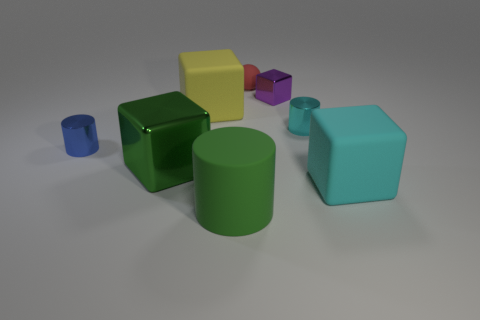Add 2 big yellow objects. How many objects exist? 10 Subtract all cylinders. How many objects are left? 5 Subtract 1 green cubes. How many objects are left? 7 Subtract all large green cylinders. Subtract all tiny purple shiny cubes. How many objects are left? 6 Add 8 metal cubes. How many metal cubes are left? 10 Add 5 gray matte things. How many gray matte things exist? 5 